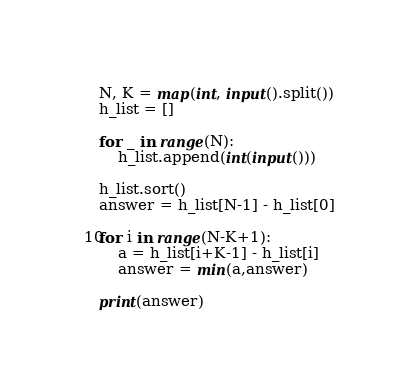<code> <loc_0><loc_0><loc_500><loc_500><_Python_>N, K = map(int, input().split())
h_list = []

for _ in range(N):
    h_list.append(int(input()))

h_list.sort()
answer = h_list[N-1] - h_list[0]

for i in range(N-K+1):
    a = h_list[i+K-1] - h_list[i]
    answer = min(a,answer)

print(answer)</code> 